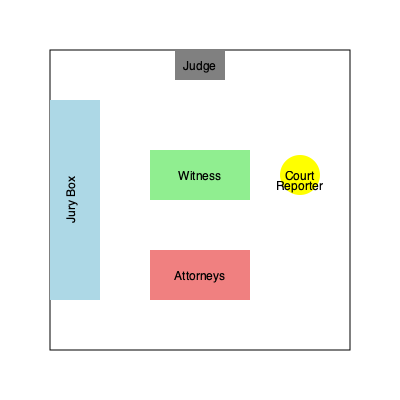Based on the courtroom layout provided, which seating arrangement for the jury would be most optimal for capturing accurate testimony, considering factors such as line of sight to the witness stand and proximity to the court reporter? To determine the optimal seating arrangement for the jury, we need to consider several factors:

1. Line of sight to the witness stand: The jury should have a clear view of the witness to observe their demeanor and body language.

2. Proximity to the court reporter: Being closer to the court reporter can ensure better audio capture of jury questions or responses if needed.

3. Distance from potential distractions: Jurors should be positioned away from areas of high activity or potential distractions.

4. Acoustic considerations: The jury should be able to hear testimony clearly.

Analyzing the layout:

a) The jury box is already positioned on the left side of the courtroom.
b) This placement provides a good angle to view the witness stand.
c) The jury is relatively close to the court reporter, who is positioned near the judge's bench.
d) This arrangement keeps the jury away from the attorneys' area, reducing potential distractions.

Given these observations, the current jury box placement is already optimal. However, to further enhance the arrangement:

1. Ensure the first row of the jury box is slightly elevated.
2. Arrange seating so that jurors in the back rows have clear sightlines over those in front.
3. If possible, curve the jury box slightly towards the witness stand for improved viewing angles.

These adjustments will maintain the current benefits while optimizing the jurors' ability to observe and hear testimony accurately.
Answer: Maintain current position with slight elevation and curvature 